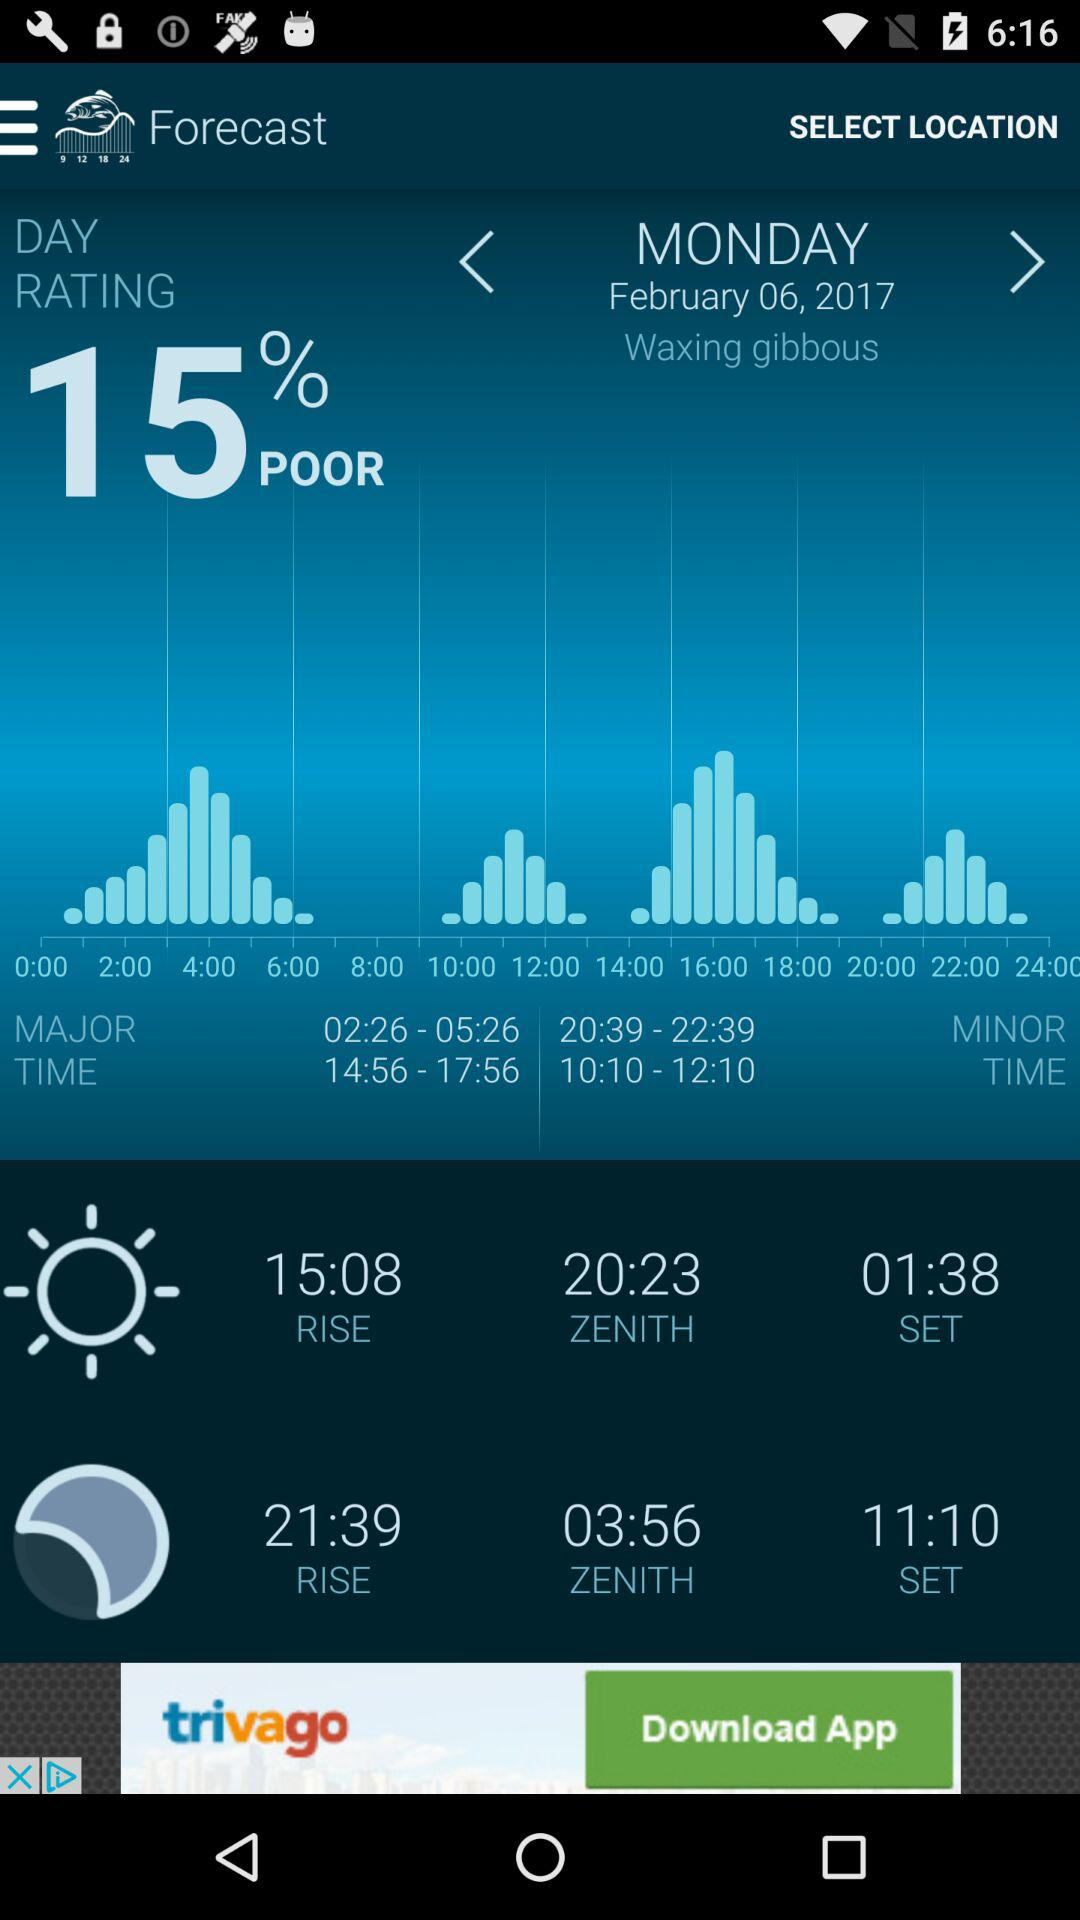What is the time of sunset? The time of sunset is 01:38. 